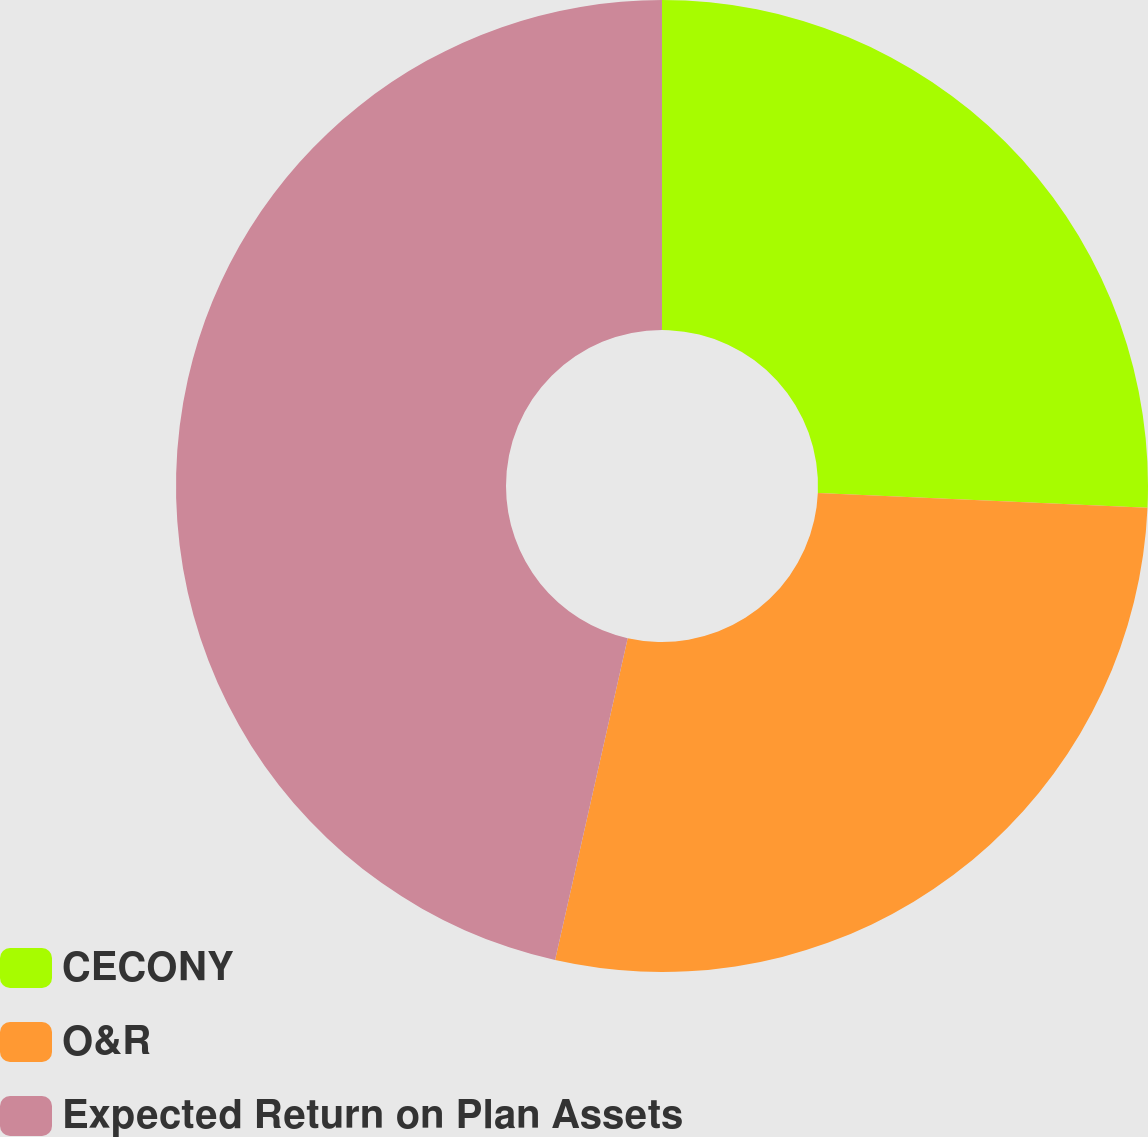<chart> <loc_0><loc_0><loc_500><loc_500><pie_chart><fcel>CECONY<fcel>O&R<fcel>Expected Return on Plan Assets<nl><fcel>25.71%<fcel>27.82%<fcel>46.47%<nl></chart> 